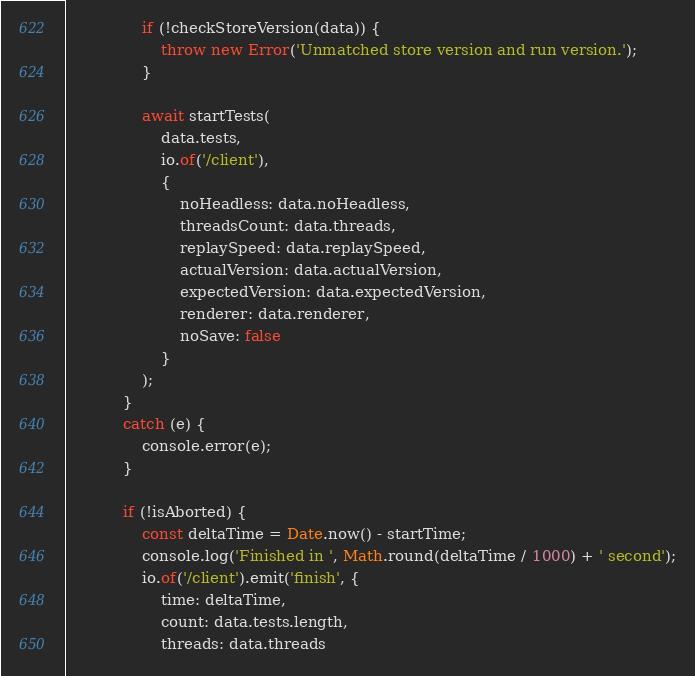<code> <loc_0><loc_0><loc_500><loc_500><_JavaScript_>                if (!checkStoreVersion(data)) {
                    throw new Error('Unmatched store version and run version.');
                }

                await startTests(
                    data.tests,
                    io.of('/client'),
                    {
                        noHeadless: data.noHeadless,
                        threadsCount: data.threads,
                        replaySpeed: data.replaySpeed,
                        actualVersion: data.actualVersion,
                        expectedVersion: data.expectedVersion,
                        renderer: data.renderer,
                        noSave: false
                    }
                );
            }
            catch (e) {
                console.error(e);
            }

            if (!isAborted) {
                const deltaTime = Date.now() - startTime;
                console.log('Finished in ', Math.round(deltaTime / 1000) + ' second');
                io.of('/client').emit('finish', {
                    time: deltaTime,
                    count: data.tests.length,
                    threads: data.threads</code> 